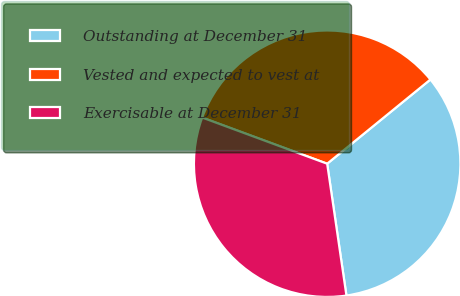Convert chart to OTSL. <chart><loc_0><loc_0><loc_500><loc_500><pie_chart><fcel>Outstanding at December 31<fcel>Vested and expected to vest at<fcel>Exercisable at December 31<nl><fcel>33.58%<fcel>33.48%<fcel>32.94%<nl></chart> 